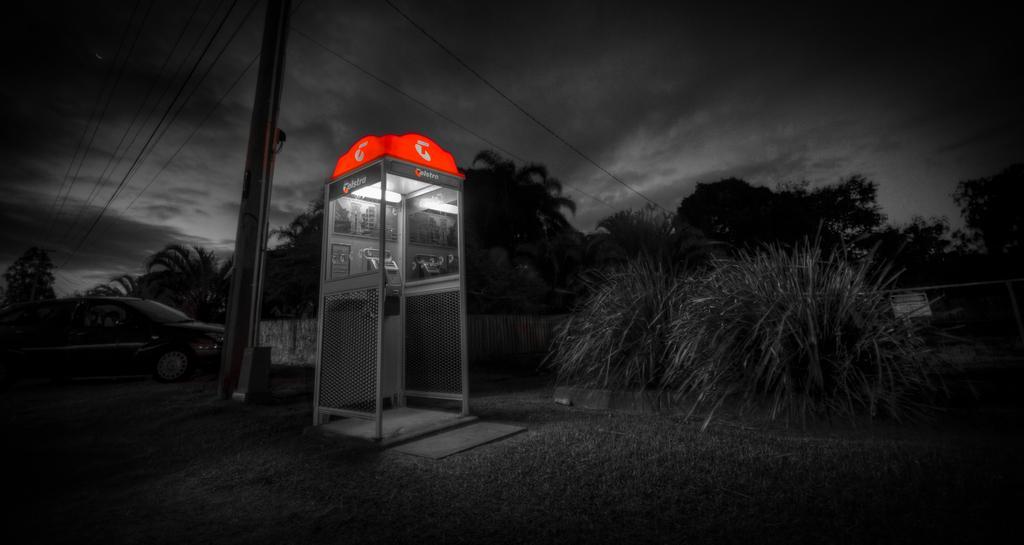Describe this image in one or two sentences. This is a booth, there are trees, this is pole with the cables, this is sky. 